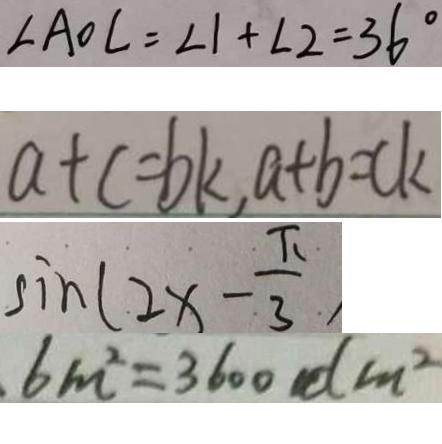Convert formula to latex. <formula><loc_0><loc_0><loc_500><loc_500>\angle A O C = \angle 1 + \angle 2 = 3 6 ^ { \circ } 
 a + c = b k , a + b = c k 
 \sin ( 2 x - \frac { \pi } { 3 } ) 
 6 m ^ { 2 } = 3 6 0 0 d m ^ { 2 }</formula> 